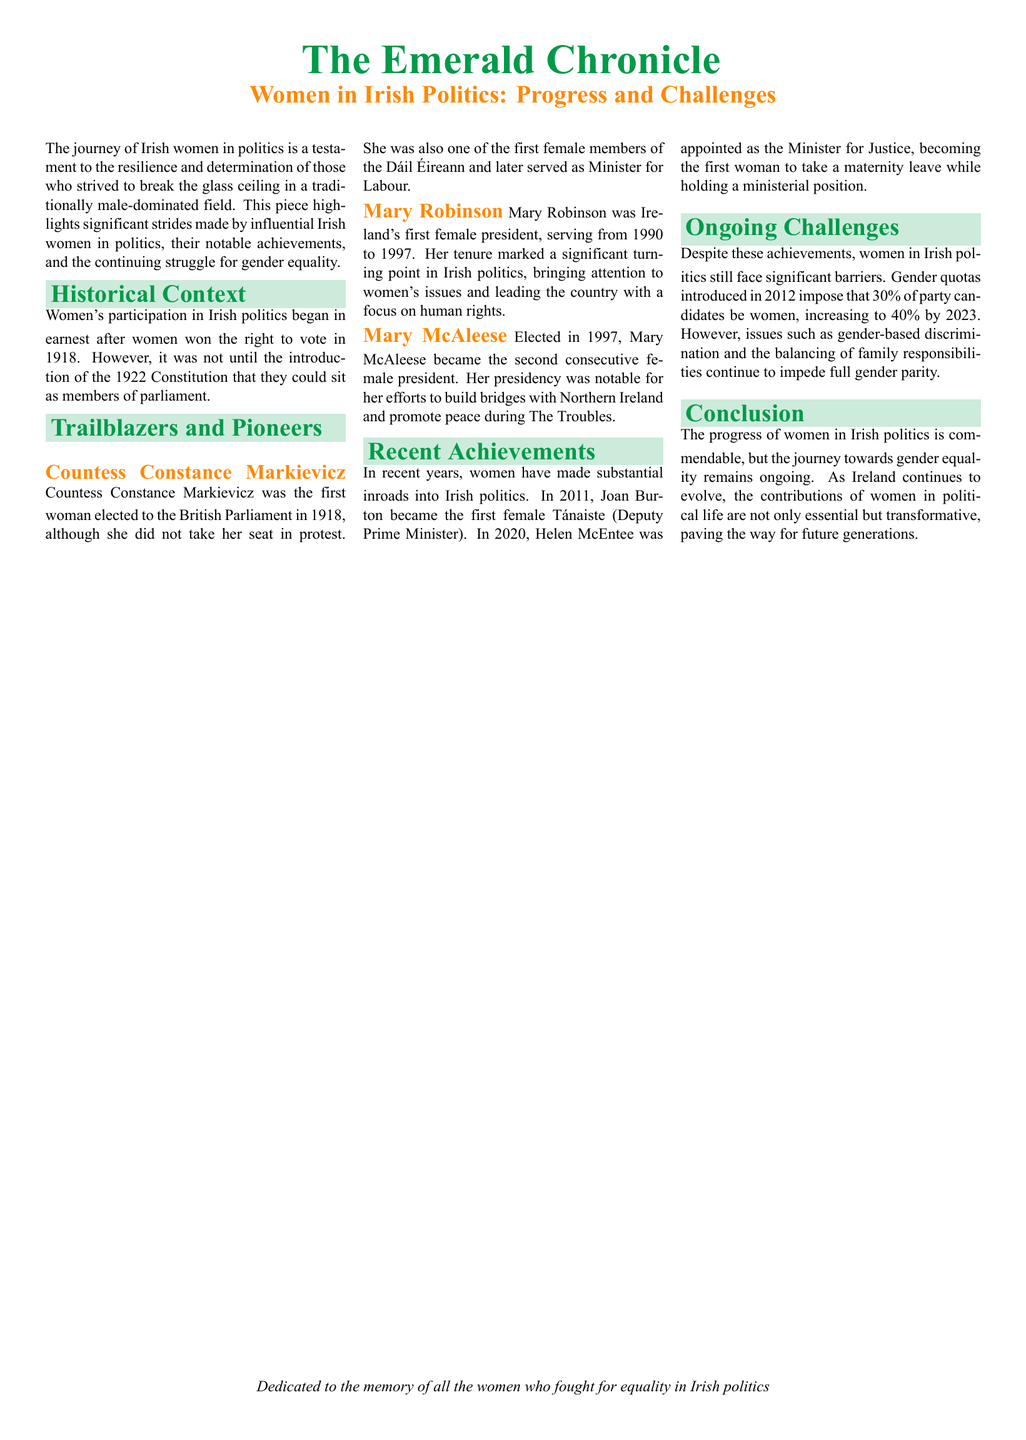What year did Countess Constance Markievicz get elected to the British Parliament? The document states that she was elected in 1918.
Answer: 1918 Who was the first female president of Ireland? The document identifies Mary Robinson as the first female president.
Answer: Mary Robinson What position did Joan Burton hold in 2011? The document mentions that she became the first female Tánaiste.
Answer: Tánaiste What was the percentage of party candidates that needed to be women under the gender quotas introduced in 2012? The document specifies that 30% of party candidates must be women.
Answer: 30% Which significant issue continues to impede full gender parity in Irish politics? The document lists gender-based discrimination as one of the ongoing challenges.
Answer: Gender-based discrimination How many women served as President of Ireland mentioned in the document? The document refers to two women: Mary Robinson and Mary McAleese.
Answer: Two What is the proposed percentage of female candidates required by 2023? The document indicates that this percentage will increase to 40% by 2023.
Answer: 40% Which political leader took maternity leave while holding a ministerial position? The document states that Helen McEntee took maternity leave while serving as Minister for Justice.
Answer: Helen McEntee In what year was Mary McAleese elected as President of Ireland? The document indicates that she was elected in 1997.
Answer: 1997 